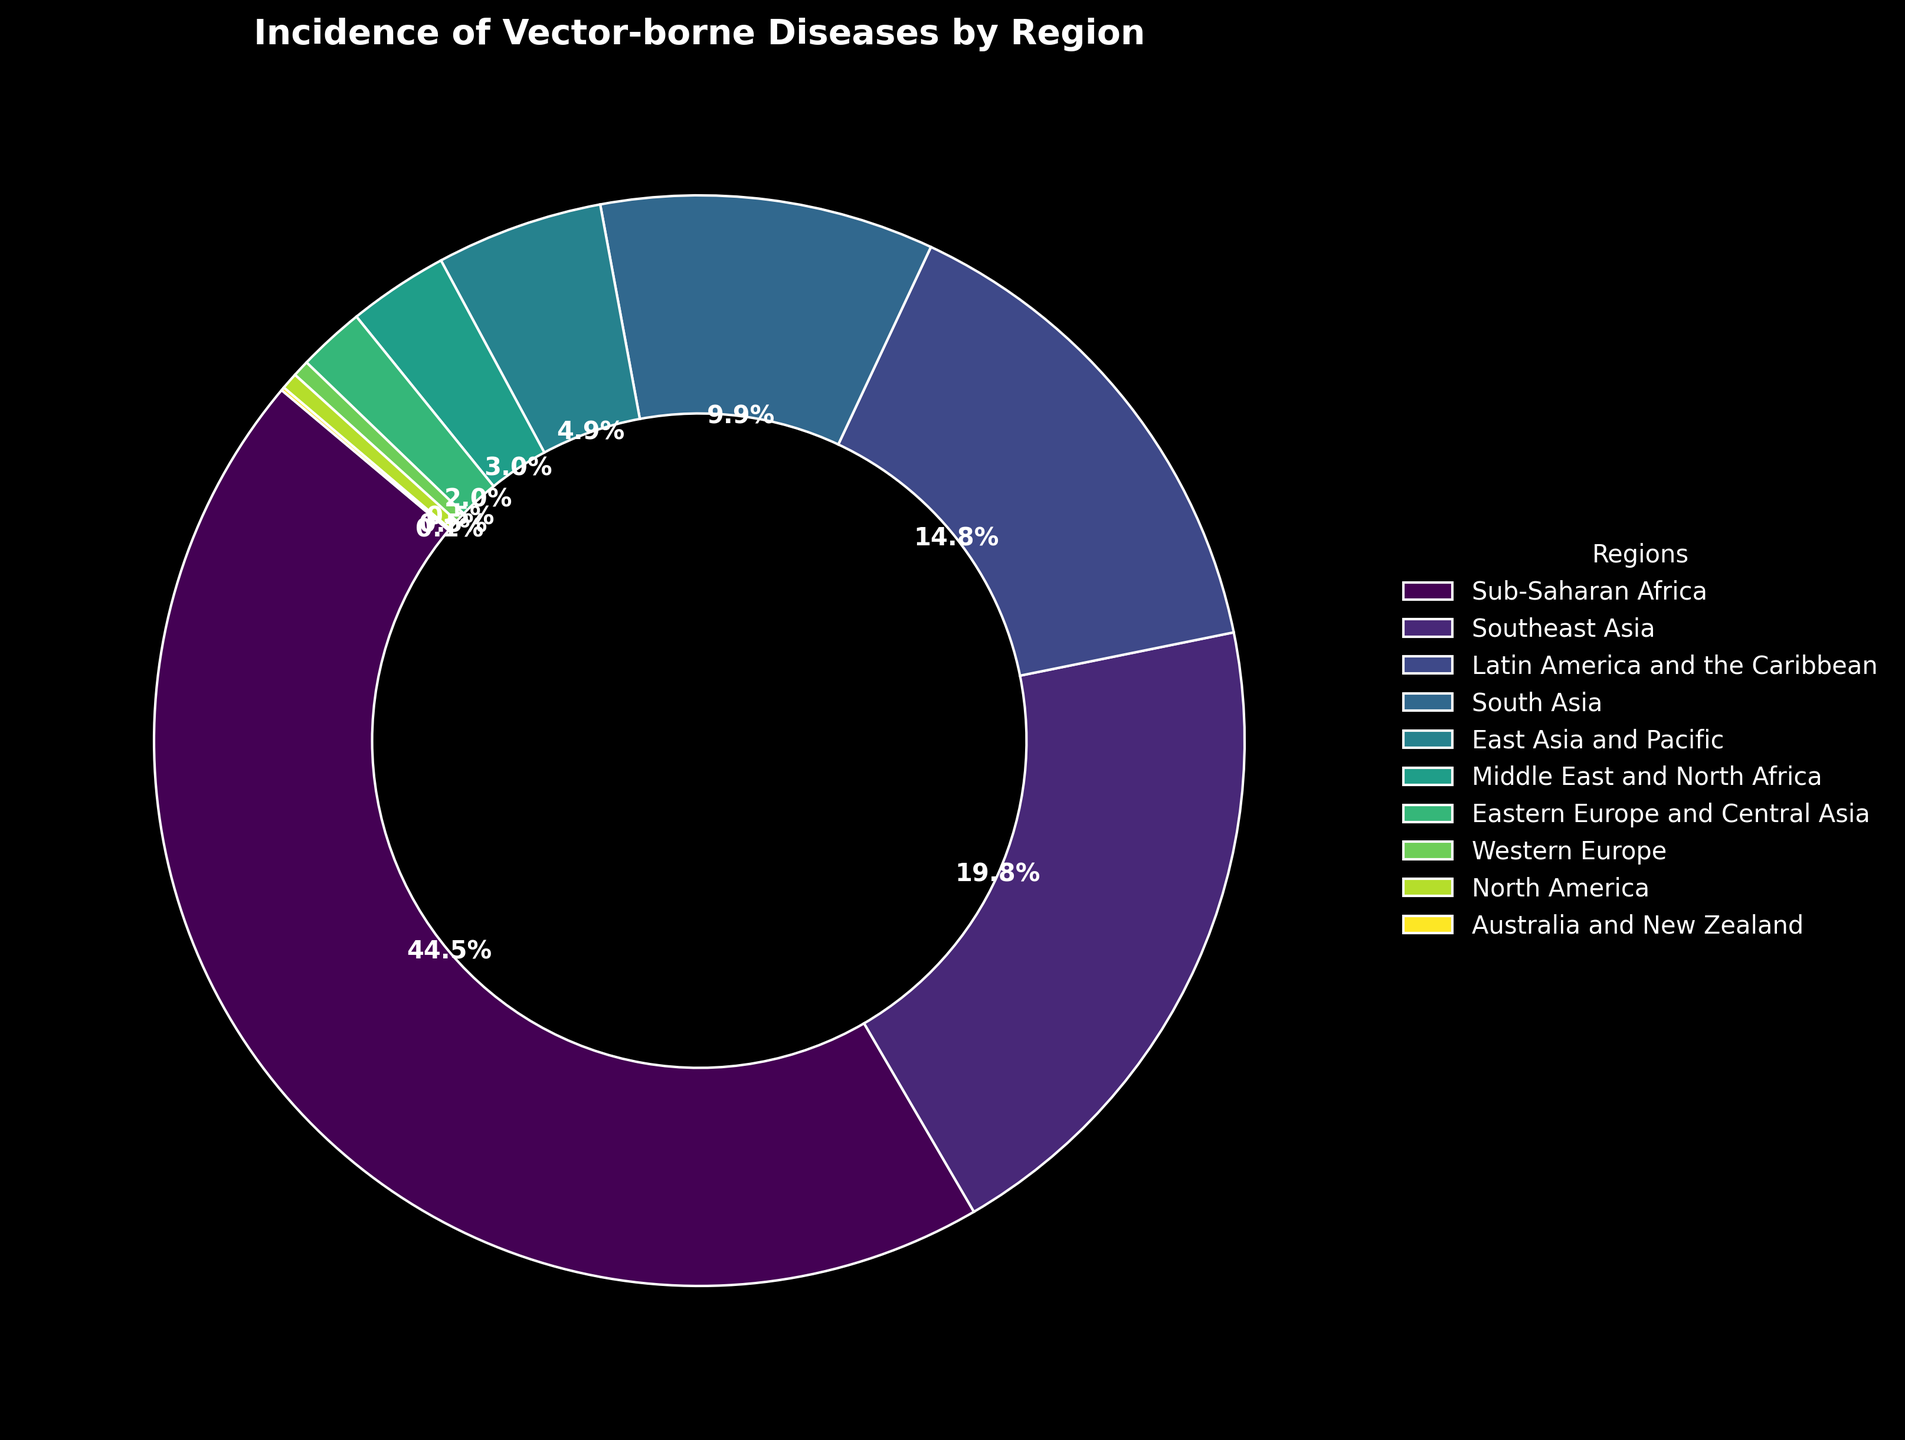What's the region with the highest incidence of vector-borne diseases? The largest portion of the ring chart corresponds to Sub-Saharan Africa.
Answer: Sub-Saharan Africa Which regions have an equal (or almost equal) incidence of vector-borne diseases? North America and Western Europe both have an almost equal incidence of 0.5%, which is visible from their small sections in the ring chart.
Answer: North America and Western Europe What percentage of vector-borne disease incidences is accounted for by South Asia and East Asia and Pacific combined? South Asia accounts for 10%, and East Asia and Pacific accounts for 5%. Summing these gives 10% + 5% = 15%.
Answer: 15% How does the incidence of vector-borne diseases in Southeast Asia compare to that in Latin America and the Caribbean? The ring chart shows that Southeast Asia has a larger section, corresponding to 20%, compared to Latin America and the Caribbean, which has 15%.
Answer: Southeast Asia has a higher incidence than Latin America and the Caribbean What is the total incidence percentage for the regions not in the top three highest incidences? The top three are Sub-Saharan Africa (45%), Southeast Asia (20%), and Latin America and the Caribbean (15%), totaling 80%. Thus, the rest account for 100% - 80% = 20%.
Answer: 20% How does the incidence in Australia and New Zealand visually compare to the other regions? The section representing Australia and New Zealand is the smallest in the ring chart, corresponding to only 0.1%. This is visually noticeable compared to the larger sections of other regions.
Answer: It has the smallest section What's the difference in vector-borne disease incidence percentages between Sub-Saharan Africa and South Asia? Sub-Saharan Africa accounts for 45%, while South Asia accounts for 10%. The difference is 45% - 10% = 35%.
Answer: 35% If you combine the incidences from Latin America and the Caribbean, South Asia, and East Asia and Pacific, are they greater than Sub-Saharan Africa alone? Latin America and the Caribbean is 15%, South Asia is 10%, and East Asia and Pacific is 5%. The sum is 15% + 10% + 5% = 30%, which is less than Sub-Saharan Africa's 45%.
Answer: No Is there any region with an incidence lower than Eastern Europe and Central Asia? Yes, both Western Europe (0.5%) and Australia and New Zealand (0.1%) have lower incidences compared to Eastern Europe and Central Asia (2%).
Answer: Yes What is the percentage increase in vector-borne disease incidence from East Asia and Pacific to Southeast Asia? East Asia and Pacific accounts for 5%, and Southeast Asia accounts for 20%. The difference is 20% - 5% = 15%, which is a 300% increase (since 15% is three times 5%).
Answer: 300% 